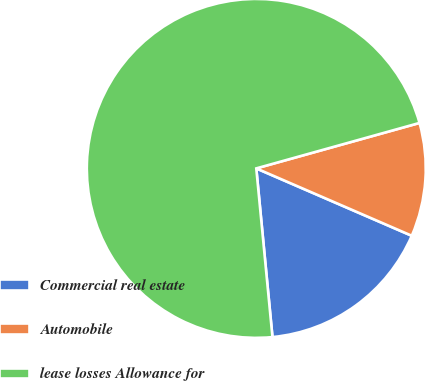Convert chart to OTSL. <chart><loc_0><loc_0><loc_500><loc_500><pie_chart><fcel>Commercial real estate<fcel>Automobile<fcel>lease losses Allowance for<nl><fcel>16.97%<fcel>10.83%<fcel>72.2%<nl></chart> 